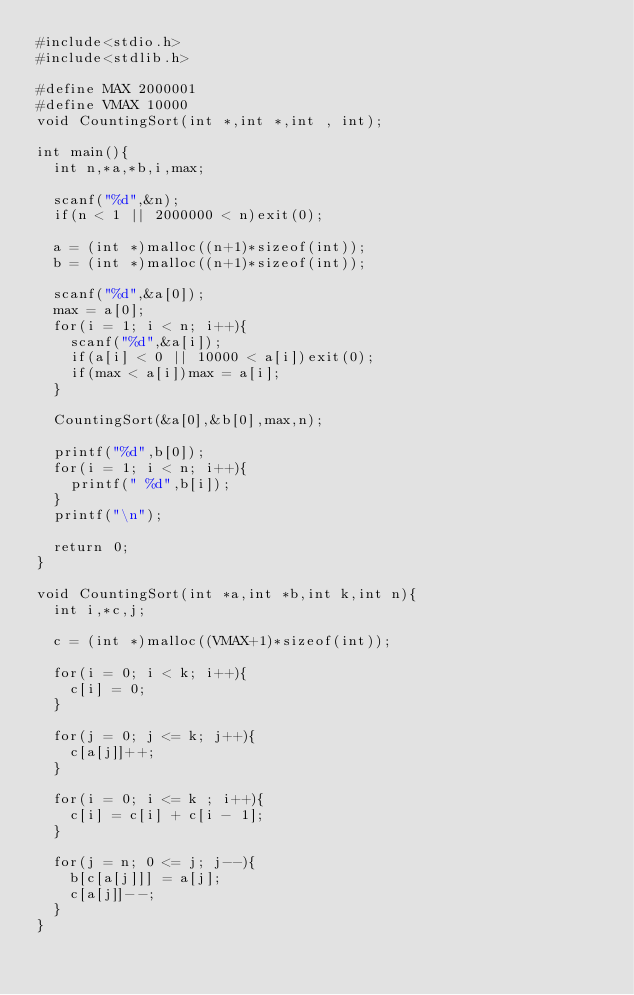<code> <loc_0><loc_0><loc_500><loc_500><_C_>#include<stdio.h>
#include<stdlib.h>

#define MAX 2000001
#define VMAX 10000
void CountingSort(int *,int *,int , int);

int main(){
  int n,*a,*b,i,max;

  scanf("%d",&n);
  if(n < 1 || 2000000 < n)exit(0);

  a = (int *)malloc((n+1)*sizeof(int));
  b = (int *)malloc((n+1)*sizeof(int));

  scanf("%d",&a[0]);
  max = a[0];
  for(i = 1; i < n; i++){
    scanf("%d",&a[i]);
    if(a[i] < 0 || 10000 < a[i])exit(0);
    if(max < a[i])max = a[i];
  }

  CountingSort(&a[0],&b[0],max,n);

  printf("%d",b[0]);
  for(i = 1; i < n; i++){
    printf(" %d",b[i]);
  }
  printf("\n");
  
  return 0;
}

void CountingSort(int *a,int *b,int k,int n){
  int i,*c,j;

  c = (int *)malloc((VMAX+1)*sizeof(int));

  for(i = 0; i < k; i++){
    c[i] = 0;    
  }

  for(j = 0; j <= k; j++){
    c[a[j]]++;
  }

  for(i = 0; i <= k ; i++){
    c[i] = c[i] + c[i - 1];
  }

  for(j = n; 0 <= j; j--){
    b[c[a[j]]] = a[j];
    c[a[j]]--;
  }
}

</code> 